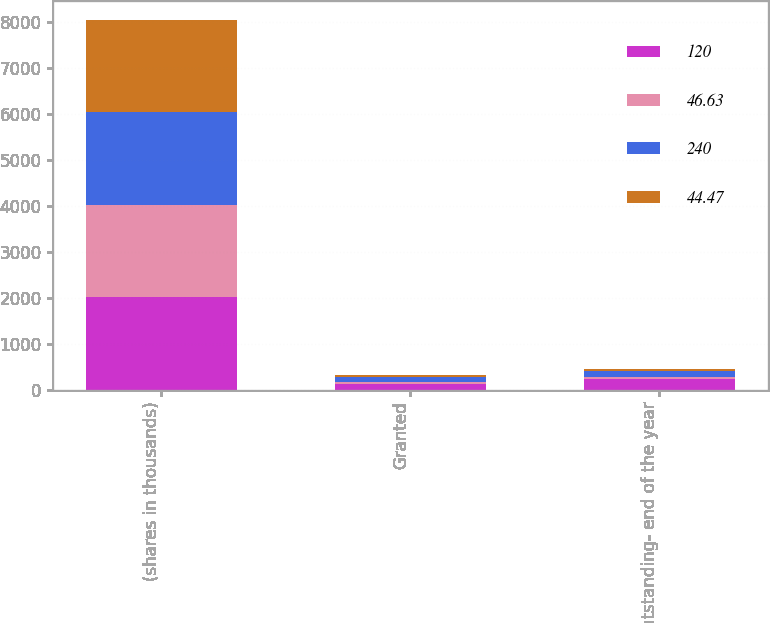<chart> <loc_0><loc_0><loc_500><loc_500><stacked_bar_chart><ecel><fcel>(shares in thousands)<fcel>Granted<fcel>Outstanding- end of the year<nl><fcel>120<fcel>2012<fcel>120<fcel>240<nl><fcel>46.63<fcel>2012<fcel>48.78<fcel>46.63<nl><fcel>240<fcel>2011<fcel>120<fcel>120<nl><fcel>44.47<fcel>2011<fcel>44.47<fcel>44.47<nl></chart> 